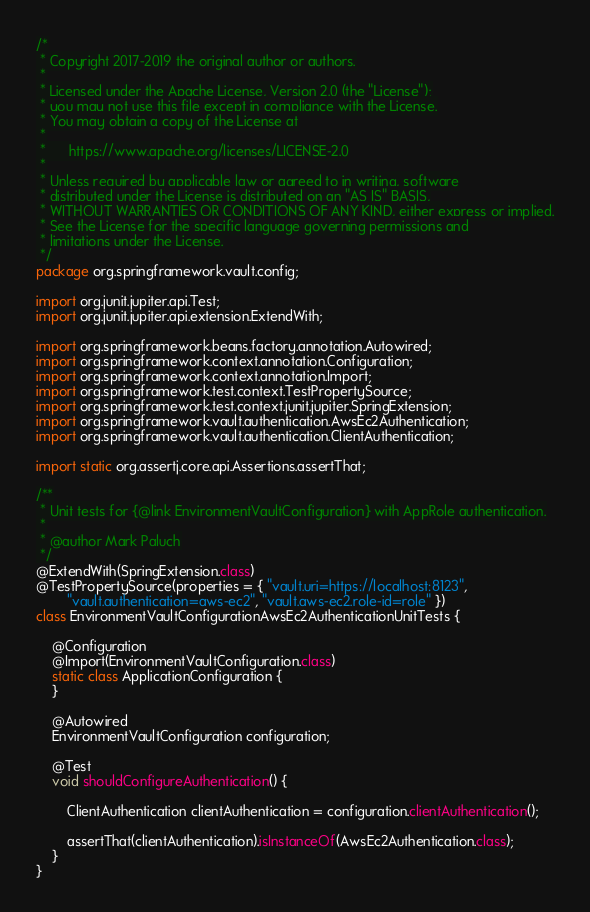Convert code to text. <code><loc_0><loc_0><loc_500><loc_500><_Java_>/*
 * Copyright 2017-2019 the original author or authors.
 *
 * Licensed under the Apache License, Version 2.0 (the "License");
 * you may not use this file except in compliance with the License.
 * You may obtain a copy of the License at
 *
 *      https://www.apache.org/licenses/LICENSE-2.0
 *
 * Unless required by applicable law or agreed to in writing, software
 * distributed under the License is distributed on an "AS IS" BASIS,
 * WITHOUT WARRANTIES OR CONDITIONS OF ANY KIND, either express or implied.
 * See the License for the specific language governing permissions and
 * limitations under the License.
 */
package org.springframework.vault.config;

import org.junit.jupiter.api.Test;
import org.junit.jupiter.api.extension.ExtendWith;

import org.springframework.beans.factory.annotation.Autowired;
import org.springframework.context.annotation.Configuration;
import org.springframework.context.annotation.Import;
import org.springframework.test.context.TestPropertySource;
import org.springframework.test.context.junit.jupiter.SpringExtension;
import org.springframework.vault.authentication.AwsEc2Authentication;
import org.springframework.vault.authentication.ClientAuthentication;

import static org.assertj.core.api.Assertions.assertThat;

/**
 * Unit tests for {@link EnvironmentVaultConfiguration} with AppRole authentication.
 *
 * @author Mark Paluch
 */
@ExtendWith(SpringExtension.class)
@TestPropertySource(properties = { "vault.uri=https://localhost:8123",
		"vault.authentication=aws-ec2", "vault.aws-ec2.role-id=role" })
class EnvironmentVaultConfigurationAwsEc2AuthenticationUnitTests {

	@Configuration
	@Import(EnvironmentVaultConfiguration.class)
	static class ApplicationConfiguration {
	}

	@Autowired
	EnvironmentVaultConfiguration configuration;

	@Test
	void shouldConfigureAuthentication() {

		ClientAuthentication clientAuthentication = configuration.clientAuthentication();

		assertThat(clientAuthentication).isInstanceOf(AwsEc2Authentication.class);
	}
}
</code> 